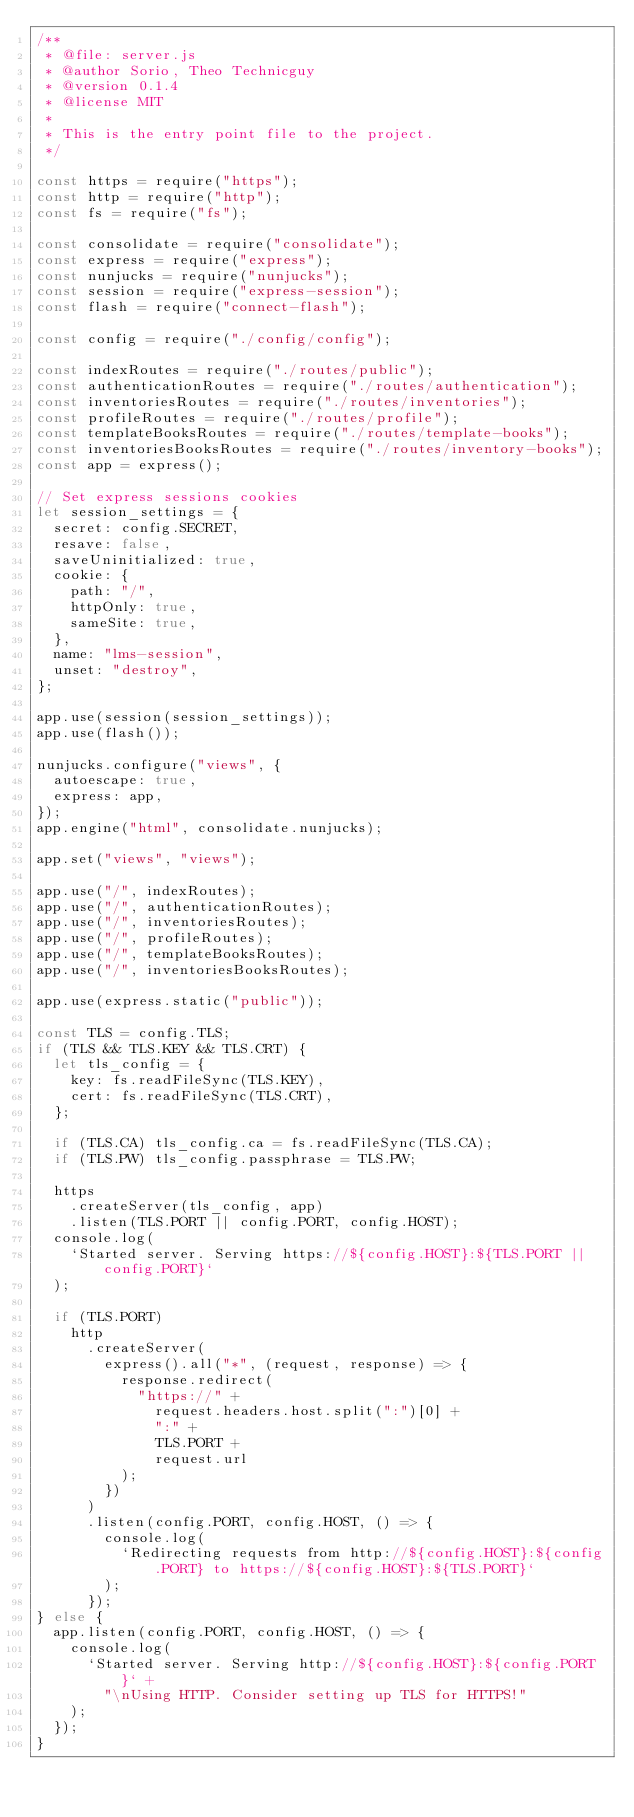Convert code to text. <code><loc_0><loc_0><loc_500><loc_500><_JavaScript_>/**
 * @file: server.js
 * @author Sorio, Theo Technicguy
 * @version 0.1.4
 * @license MIT
 *
 * This is the entry point file to the project.
 */

const https = require("https");
const http = require("http");
const fs = require("fs");

const consolidate = require("consolidate");
const express = require("express");
const nunjucks = require("nunjucks");
const session = require("express-session");
const flash = require("connect-flash");

const config = require("./config/config");

const indexRoutes = require("./routes/public");
const authenticationRoutes = require("./routes/authentication");
const inventoriesRoutes = require("./routes/inventories");
const profileRoutes = require("./routes/profile");
const templateBooksRoutes = require("./routes/template-books");
const inventoriesBooksRoutes = require("./routes/inventory-books");
const app = express();

// Set express sessions cookies
let session_settings = {
  secret: config.SECRET,
  resave: false,
  saveUninitialized: true,
  cookie: {
    path: "/",
    httpOnly: true,
    sameSite: true,
  },
  name: "lms-session",
  unset: "destroy",
};

app.use(session(session_settings));
app.use(flash());

nunjucks.configure("views", {
  autoescape: true,
  express: app,
});
app.engine("html", consolidate.nunjucks);

app.set("views", "views");

app.use("/", indexRoutes);
app.use("/", authenticationRoutes);
app.use("/", inventoriesRoutes);
app.use("/", profileRoutes);
app.use("/", templateBooksRoutes);
app.use("/", inventoriesBooksRoutes);

app.use(express.static("public"));

const TLS = config.TLS;
if (TLS && TLS.KEY && TLS.CRT) {
  let tls_config = {
    key: fs.readFileSync(TLS.KEY),
    cert: fs.readFileSync(TLS.CRT),
  };

  if (TLS.CA) tls_config.ca = fs.readFileSync(TLS.CA);
  if (TLS.PW) tls_config.passphrase = TLS.PW;

  https
    .createServer(tls_config, app)
    .listen(TLS.PORT || config.PORT, config.HOST);
  console.log(
    `Started server. Serving https://${config.HOST}:${TLS.PORT || config.PORT}`
  );

  if (TLS.PORT)
    http
      .createServer(
        express().all("*", (request, response) => {
          response.redirect(
            "https://" +
              request.headers.host.split(":")[0] +
              ":" +
              TLS.PORT +
              request.url
          );
        })
      )
      .listen(config.PORT, config.HOST, () => {
        console.log(
          `Redirecting requests from http://${config.HOST}:${config.PORT} to https://${config.HOST}:${TLS.PORT}`
        );
      });
} else {
  app.listen(config.PORT, config.HOST, () => {
    console.log(
      `Started server. Serving http://${config.HOST}:${config.PORT}` +
        "\nUsing HTTP. Consider setting up TLS for HTTPS!"
    );
  });
}
</code> 